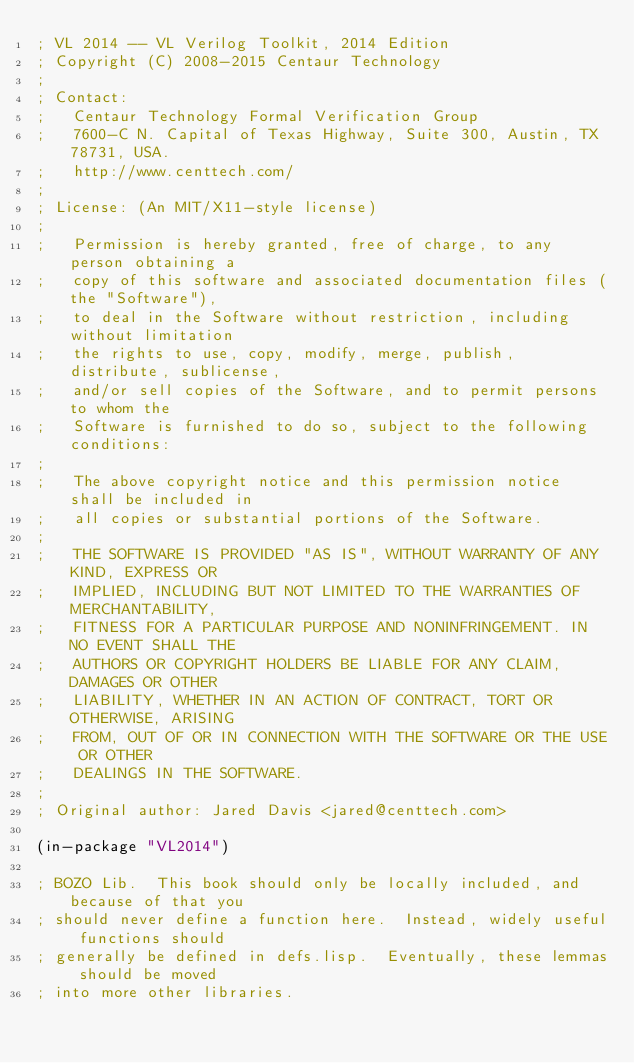<code> <loc_0><loc_0><loc_500><loc_500><_Lisp_>; VL 2014 -- VL Verilog Toolkit, 2014 Edition
; Copyright (C) 2008-2015 Centaur Technology
;
; Contact:
;   Centaur Technology Formal Verification Group
;   7600-C N. Capital of Texas Highway, Suite 300, Austin, TX 78731, USA.
;   http://www.centtech.com/
;
; License: (An MIT/X11-style license)
;
;   Permission is hereby granted, free of charge, to any person obtaining a
;   copy of this software and associated documentation files (the "Software"),
;   to deal in the Software without restriction, including without limitation
;   the rights to use, copy, modify, merge, publish, distribute, sublicense,
;   and/or sell copies of the Software, and to permit persons to whom the
;   Software is furnished to do so, subject to the following conditions:
;
;   The above copyright notice and this permission notice shall be included in
;   all copies or substantial portions of the Software.
;
;   THE SOFTWARE IS PROVIDED "AS IS", WITHOUT WARRANTY OF ANY KIND, EXPRESS OR
;   IMPLIED, INCLUDING BUT NOT LIMITED TO THE WARRANTIES OF MERCHANTABILITY,
;   FITNESS FOR A PARTICULAR PURPOSE AND NONINFRINGEMENT. IN NO EVENT SHALL THE
;   AUTHORS OR COPYRIGHT HOLDERS BE LIABLE FOR ANY CLAIM, DAMAGES OR OTHER
;   LIABILITY, WHETHER IN AN ACTION OF CONTRACT, TORT OR OTHERWISE, ARISING
;   FROM, OUT OF OR IN CONNECTION WITH THE SOFTWARE OR THE USE OR OTHER
;   DEALINGS IN THE SOFTWARE.
;
; Original author: Jared Davis <jared@centtech.com>

(in-package "VL2014")

; BOZO Lib.  This book should only be locally included, and because of that you
; should never define a function here.  Instead, widely useful functions should
; generally be defined in defs.lisp.  Eventually, these lemmas should be moved
; into more other libraries.

</code> 